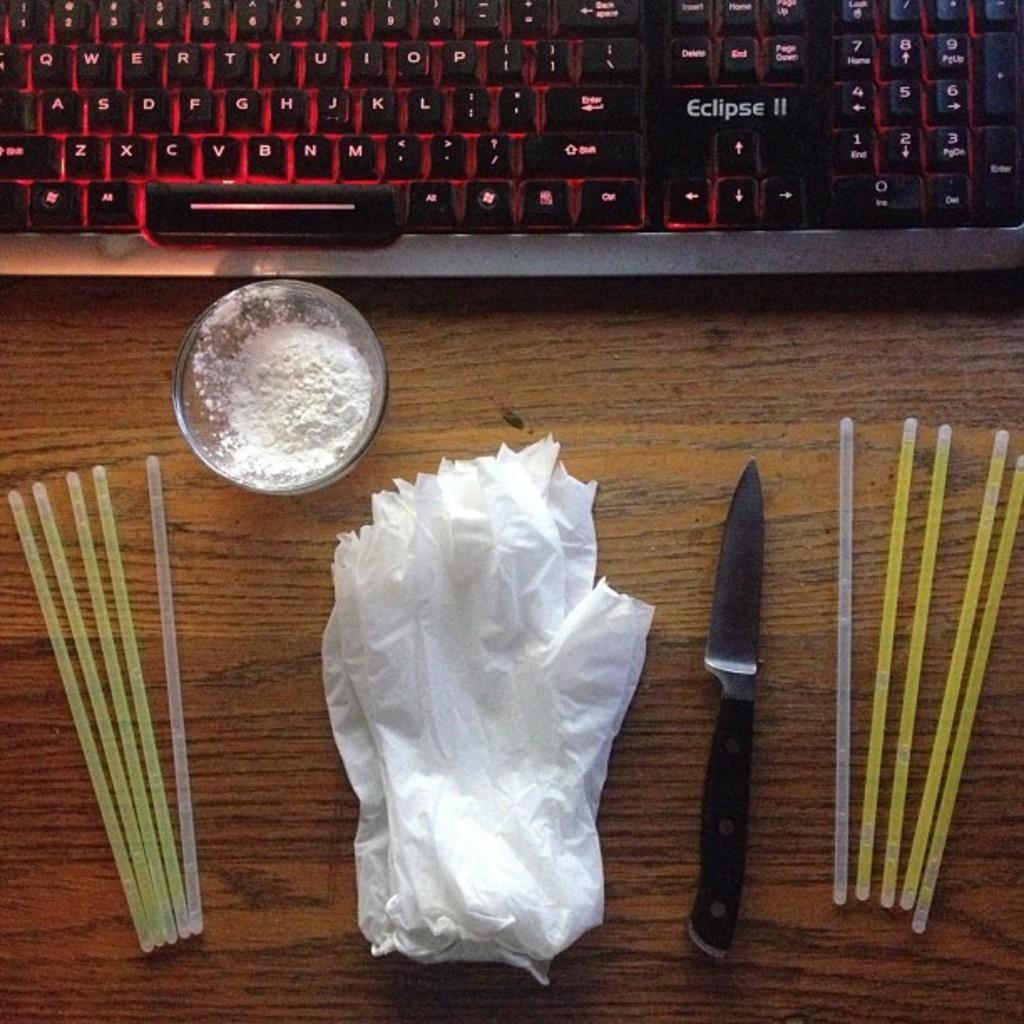How would you summarize this image in a sentence or two? This is a wooden table where a keyboard, a glass bowl, a knife and a tissues are kept on it. 